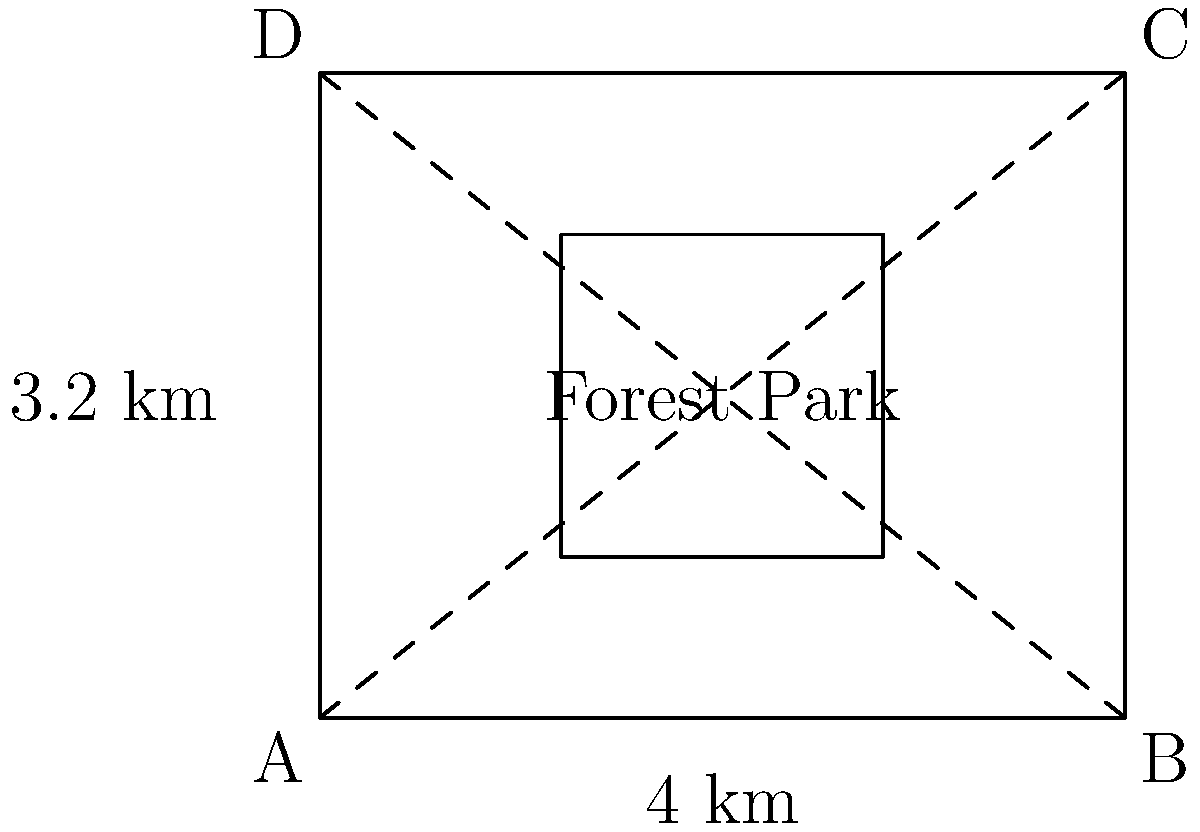As a new resident of St. Louis interested in local culture, you're exploring Forest Park using satellite imagery. The park can be approximated as a rectangle with diagonals, as shown in the image. If the width of the park is 4 km and the length is 3.2 km, estimate the area of Forest Park in square kilometers. Round your answer to one decimal place. To estimate the area of Forest Park, we'll use the formula for the area of a rectangle:

1) Area = length × width

2) We're given:
   Width = 4 km
   Length = 3.2 km

3) Plugging these values into the formula:
   Area = 3.2 km × 4 km = 12.8 km²

4) Rounding to one decimal place:
   Area ≈ 12.8 km²

This method provides a good estimation of the park's area using basic geometric principles and the given satellite imagery approximation.
Answer: 12.8 km² 